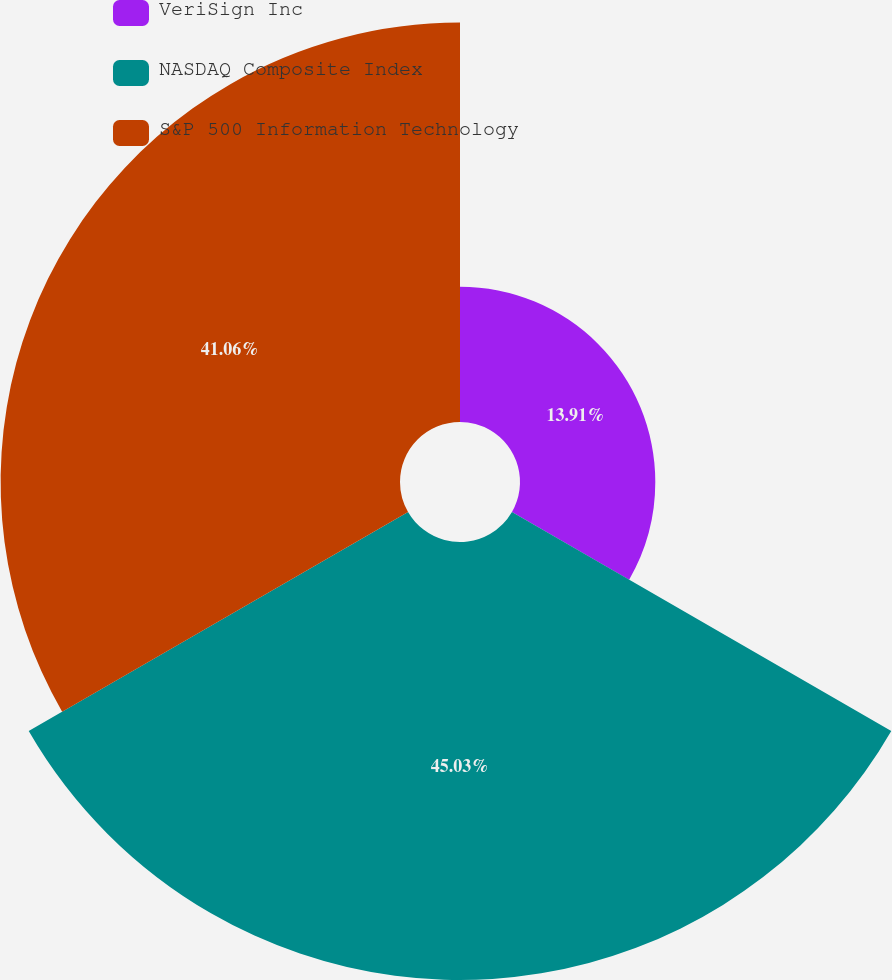Convert chart. <chart><loc_0><loc_0><loc_500><loc_500><pie_chart><fcel>VeriSign Inc<fcel>NASDAQ Composite Index<fcel>S&P 500 Information Technology<nl><fcel>13.91%<fcel>45.03%<fcel>41.06%<nl></chart> 